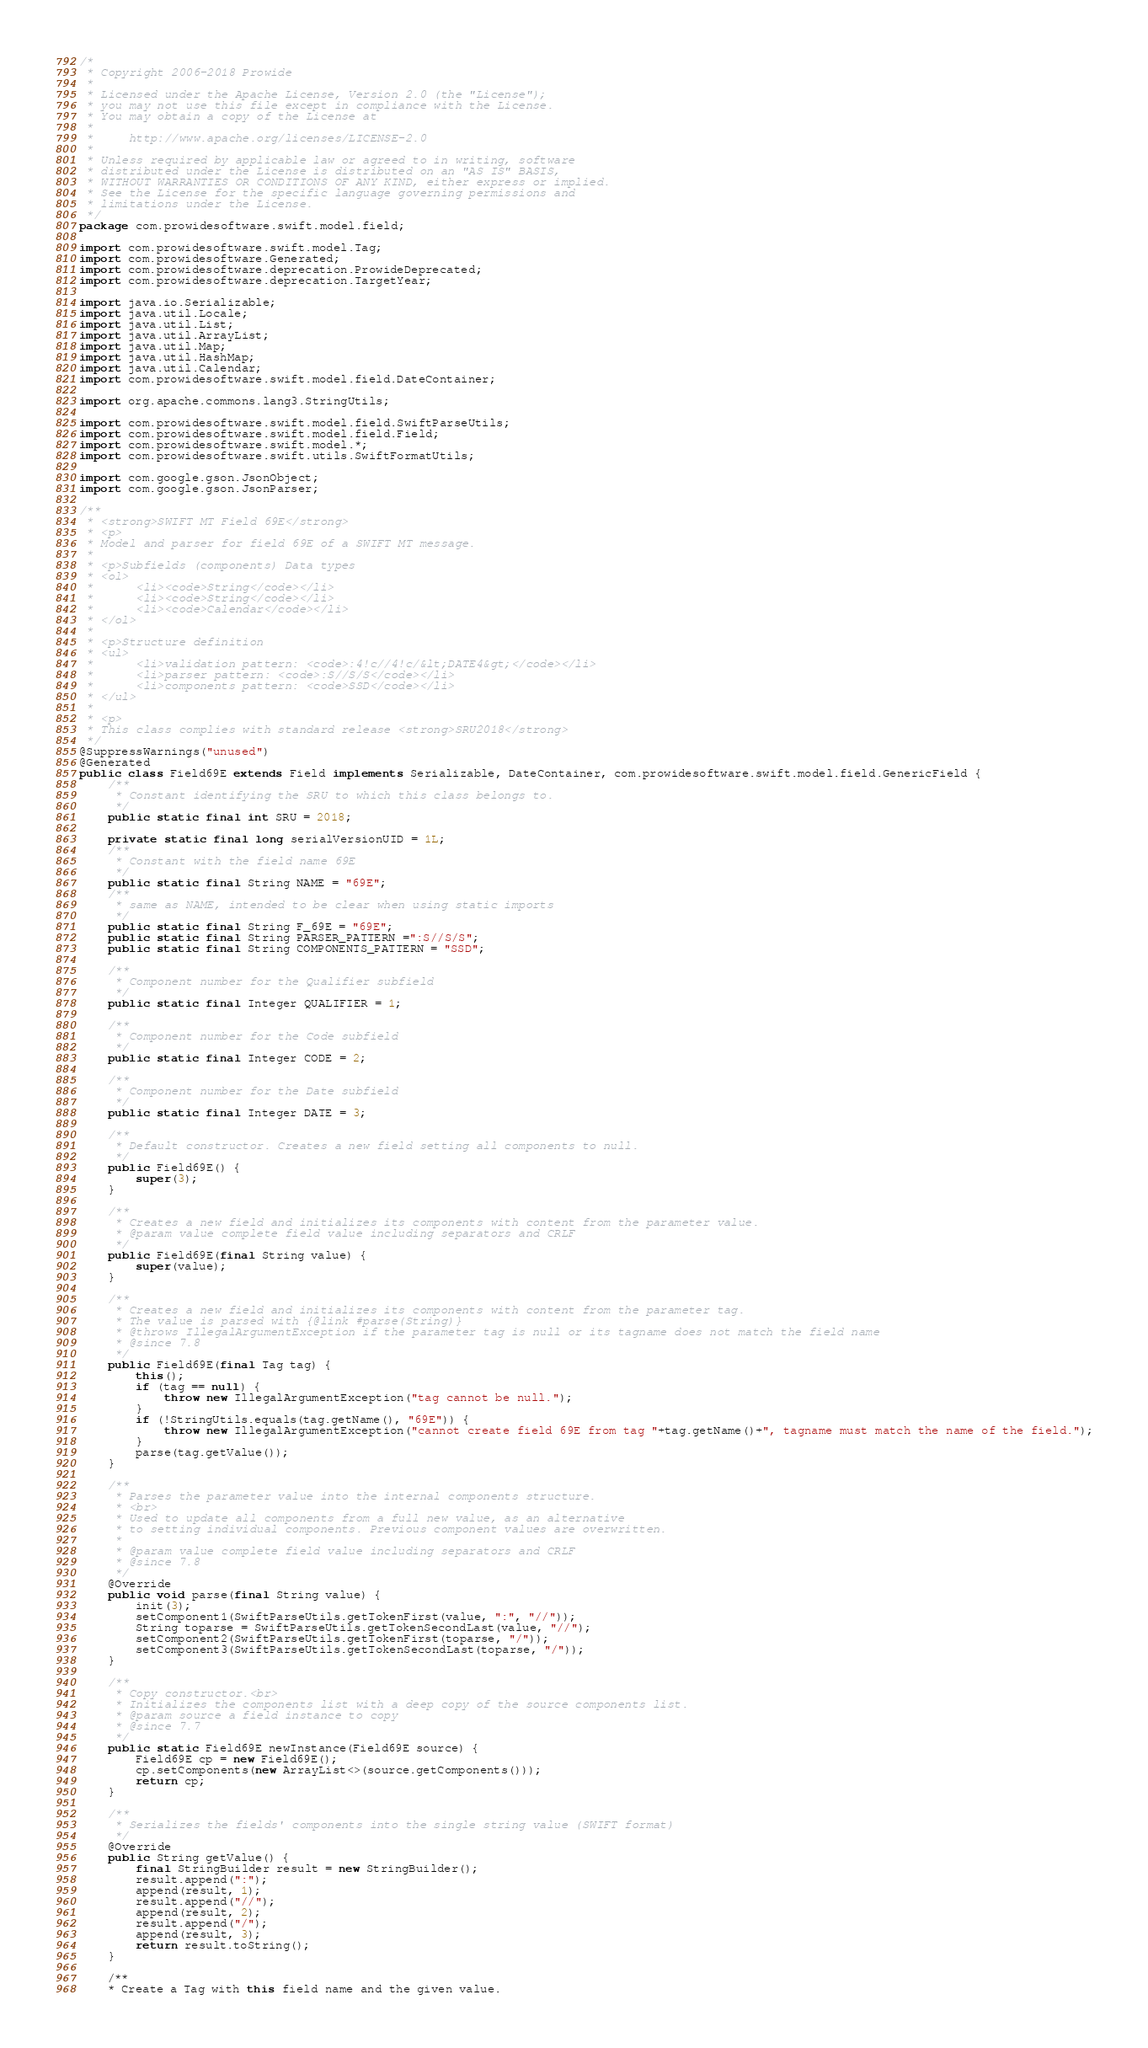<code> <loc_0><loc_0><loc_500><loc_500><_Java_>/*
 * Copyright 2006-2018 Prowide
 *
 * Licensed under the Apache License, Version 2.0 (the "License");
 * you may not use this file except in compliance with the License.
 * You may obtain a copy of the License at
 *
 *     http://www.apache.org/licenses/LICENSE-2.0
 *
 * Unless required by applicable law or agreed to in writing, software
 * distributed under the License is distributed on an "AS IS" BASIS,
 * WITHOUT WARRANTIES OR CONDITIONS OF ANY KIND, either express or implied.
 * See the License for the specific language governing permissions and
 * limitations under the License.
 */
package com.prowidesoftware.swift.model.field;

import com.prowidesoftware.swift.model.Tag;
import com.prowidesoftware.Generated;
import com.prowidesoftware.deprecation.ProwideDeprecated;
import com.prowidesoftware.deprecation.TargetYear;

import java.io.Serializable;
import java.util.Locale;
import java.util.List;
import java.util.ArrayList;
import java.util.Map;
import java.util.HashMap;
import java.util.Calendar;
import com.prowidesoftware.swift.model.field.DateContainer;

import org.apache.commons.lang3.StringUtils;

import com.prowidesoftware.swift.model.field.SwiftParseUtils;
import com.prowidesoftware.swift.model.field.Field;
import com.prowidesoftware.swift.model.*;
import com.prowidesoftware.swift.utils.SwiftFormatUtils;

import com.google.gson.JsonObject;
import com.google.gson.JsonParser;

/**
 * <strong>SWIFT MT Field 69E</strong>
 * <p>
 * Model and parser for field 69E of a SWIFT MT message.
 *
 * <p>Subfields (components) Data types
 * <ol> 
 * 		<li><code>String</code></li> 
 * 		<li><code>String</code></li> 
 * 		<li><code>Calendar</code></li> 
 * </ol>
 *
 * <p>Structure definition
 * <ul>
 * 		<li>validation pattern: <code>:4!c//4!c/&lt;DATE4&gt;</code></li>
 * 		<li>parser pattern: <code>:S//S/S</code></li>
 * 		<li>components pattern: <code>SSD</code></li>
 * </ul>
 *		 
 * <p>
 * This class complies with standard release <strong>SRU2018</strong>
 */
@SuppressWarnings("unused") 
@Generated
public class Field69E extends Field implements Serializable, DateContainer, com.prowidesoftware.swift.model.field.GenericField {
	/**
	 * Constant identifying the SRU to which this class belongs to.
	 */
	public static final int SRU = 2018;

	private static final long serialVersionUID = 1L;
	/**
	 * Constant with the field name 69E
	 */
    public static final String NAME = "69E";
    /**
     * same as NAME, intended to be clear when using static imports
     */
    public static final String F_69E = "69E";
	public static final String PARSER_PATTERN =":S//S/S";
	public static final String COMPONENTS_PATTERN = "SSD";

	/**
	 * Component number for the Qualifier subfield
	 */
	public static final Integer QUALIFIER = 1;

	/**
	 * Component number for the Code subfield
	 */
	public static final Integer CODE = 2;

	/**
	 * Component number for the Date subfield
	 */
	public static final Integer DATE = 3;

	/**
	 * Default constructor. Creates a new field setting all components to null.
	 */
	public Field69E() {
		super(3);
	}
	    					
	/**
	 * Creates a new field and initializes its components with content from the parameter value.
	 * @param value complete field value including separators and CRLF
	 */
	public Field69E(final String value) {
		super(value);
	}
	
	/**
	 * Creates a new field and initializes its components with content from the parameter tag.
	 * The value is parsed with {@link #parse(String)} 	 
	 * @throws IllegalArgumentException if the parameter tag is null or its tagname does not match the field name
	 * @since 7.8
	 */
	public Field69E(final Tag tag) {
		this();
		if (tag == null) {
			throw new IllegalArgumentException("tag cannot be null.");
		}
		if (!StringUtils.equals(tag.getName(), "69E")) {
			throw new IllegalArgumentException("cannot create field 69E from tag "+tag.getName()+", tagname must match the name of the field.");
		}
		parse(tag.getValue());
	}
	
	/**
	 * Parses the parameter value into the internal components structure.
	 * <br>
	 * Used to update all components from a full new value, as an alternative
	 * to setting individual components. Previous component values are overwritten.
	 *
	 * @param value complete field value including separators and CRLF
	 * @since 7.8
	 */
	@Override
	public void parse(final String value) {
		init(3);
		setComponent1(SwiftParseUtils.getTokenFirst(value, ":", "//"));
		String toparse = SwiftParseUtils.getTokenSecondLast(value, "//");
		setComponent2(SwiftParseUtils.getTokenFirst(toparse, "/"));
		setComponent3(SwiftParseUtils.getTokenSecondLast(toparse, "/"));
	}
	
	/**
	 * Copy constructor.<br>
	 * Initializes the components list with a deep copy of the source components list.
	 * @param source a field instance to copy
	 * @since 7.7
	 */
	public static Field69E newInstance(Field69E source) {
		Field69E cp = new Field69E();
		cp.setComponents(new ArrayList<>(source.getComponents()));
		return cp;
	}
	
	/**
	 * Serializes the fields' components into the single string value (SWIFT format)
	 */
	@Override
	public String getValue() {
		final StringBuilder result = new StringBuilder();
		result.append(":");
		append(result, 1);
		result.append("//");
		append(result, 2);
		result.append("/");
		append(result, 3);
		return result.toString();
	}

	/**
	* Create a Tag with this field name and the given value.</code> 